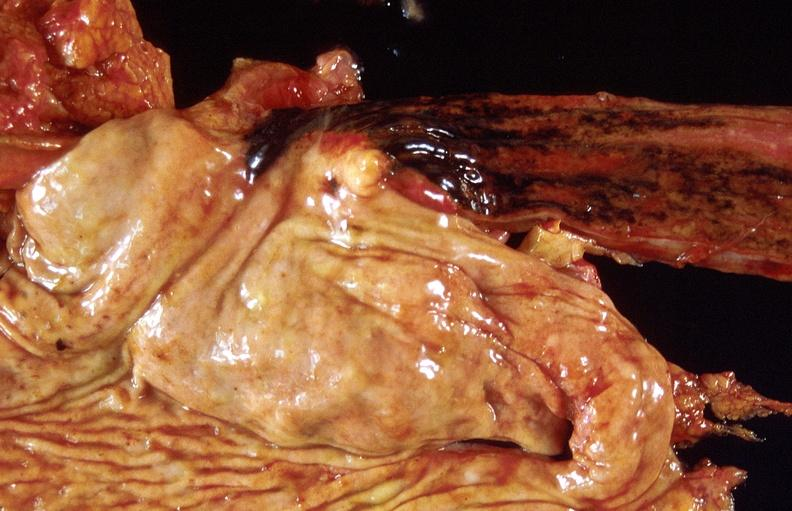where does this belong to?
Answer the question using a single word or phrase. Gastrointestinal system 